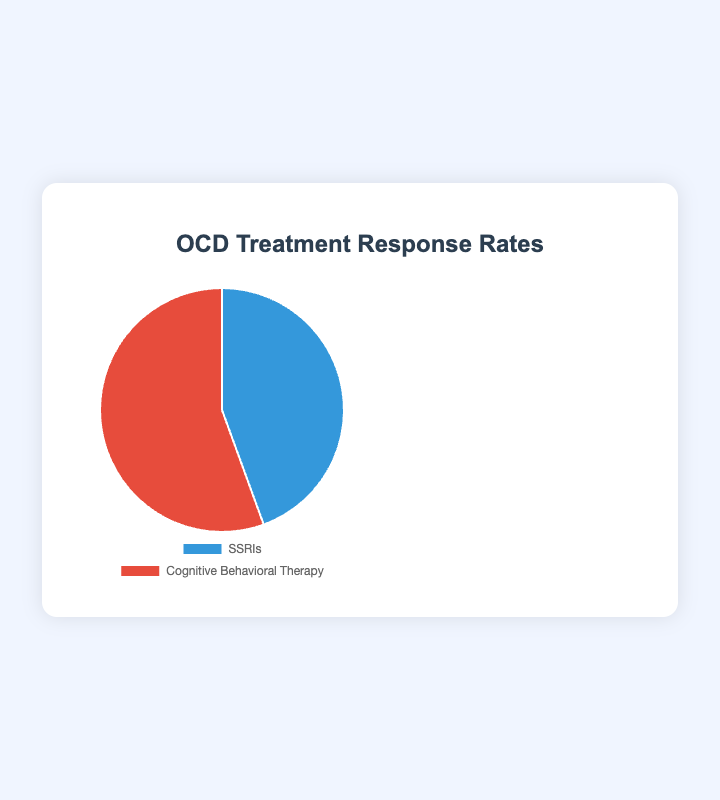What is the percentage of patients responding to SSRIs? The figure shows a pie chart with response rates for SSRIs and Cognitive Behavioral Therapy. The section for SSRIs is labeled as 60%.
Answer: 60% What is the difference in response rates between SSRIs and Cognitive Behavioral Therapy? The response rate for SSRIs is 60% and for Cognitive Behavioral Therapy is 75%. Subtracting 60% from 75% gives a difference of 15%.
Answer: 15% Which treatment has a higher response rate? By comparing the two sections of the pie chart, the section for Cognitive Behavioral Therapy is larger, indicating a higher response rate of 75% compared to 60% for SSRIs.
Answer: Cognitive Behavioral Therapy What percentage of patients responds positively to Cognitive Behavioral Therapy? The figure shows a pie chart with response rates for SSRIs and Cognitive Behavioral Therapy, where Cognitive Behavioral Therapy is labeled as 75%.
Answer: 75% Calculate the average response rate of SSRIs and Cognitive Behavioral Therapy. The response rates are 60% for SSRIs and 75% for Cognitive Behavioral Therapy. Adding these (60 + 75) gives 135, and the average is 135/2 = 67.5%.
Answer: 67.5% If there are 100 patients, how many would respond to SSRIs based on the given percentage? With a response rate of 60% for SSRIs, out of 100 patients, 60% of 100 gives 60 patients.
Answer: 60 If there are 200 patients in total, how many are expected to respond positively to either treatment? The response rates are 60% for SSRIs and 75% for Cognitive Behavioral Therapy. For 200 patients, (60% of 200) for SSRIs is 120 patients, and (75% of 200) for Cognitive Behavioral Therapy is 150 patients. Summing these gives 120 + 150 = 270 patients.
Answer: 270 What proportion of the pie chart is occupied by the section representing Cognitive Behavioral Therapy? The pie chart shows two sections, one for SSRIs (60%) and one for Cognitive Behavioral Therapy (75%). Since these percentages add up to more than 100%, the proportions should primarily be seen in terms of relative sizes. However, the Cognitive Behavioral Therapy section is larger, visually representing its higher percentage value.
Answer: Largest section What color represents Cognitive Behavioral Therapy in the pie chart? The pie chart uses different colors for SSRIs and Cognitive Behavioral Therapy. The section for Cognitive Behavioral Therapy is colored red.
Answer: Red 